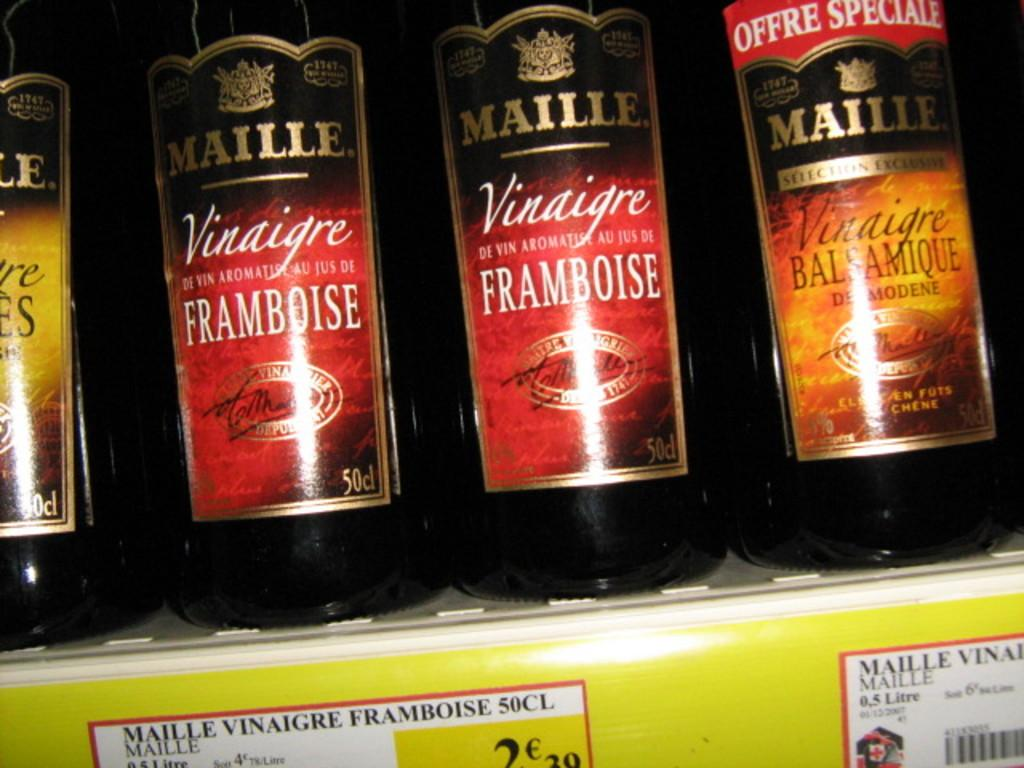<image>
Describe the image concisely. The brand of the vinegar in the store is Maille 